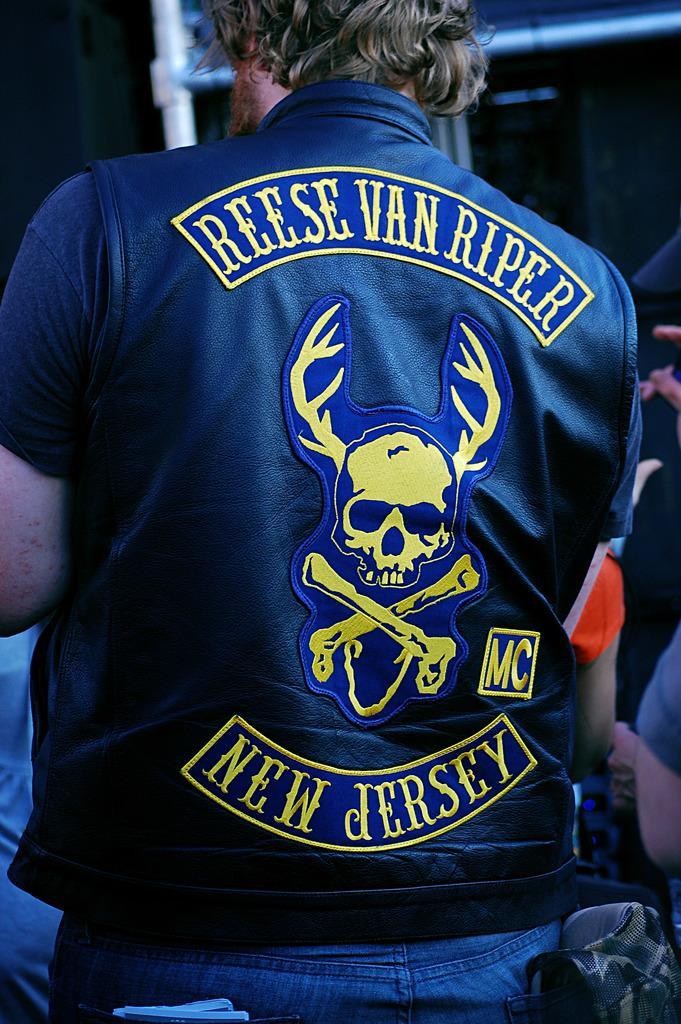Please provide a concise description of this image. In this image I can see a person standing and the person is wearing blue shirt, blue pant. Background I can see few other persons and a pole. 